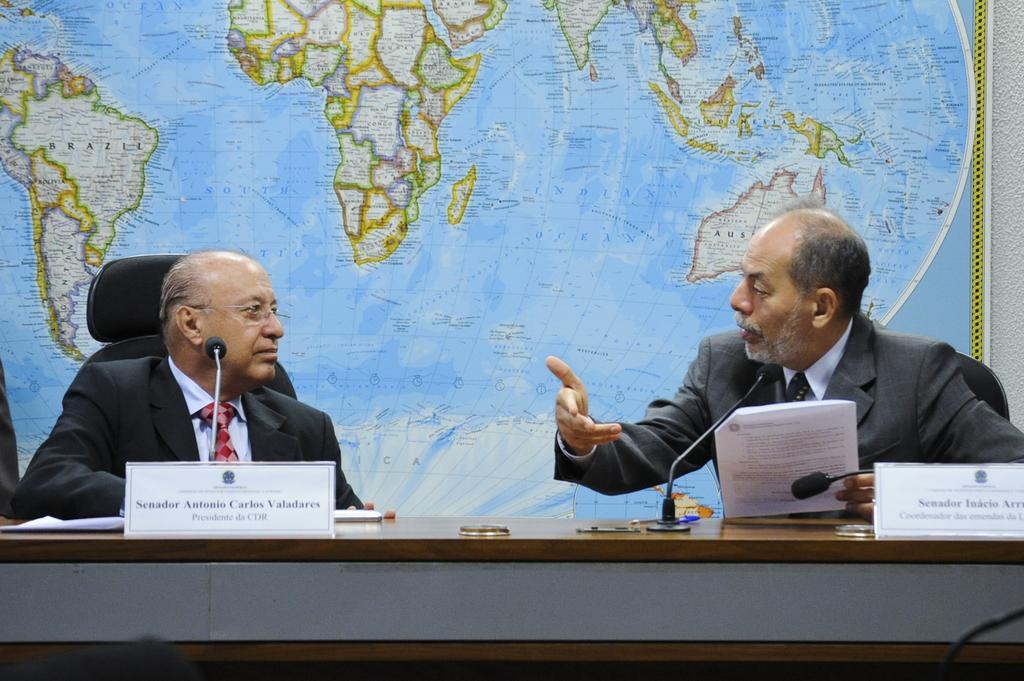Please provide a concise description of this image. In the background we can see a map board on the wall. In this picture we can see the men sitting on the chairs and it seems like they are discussing. On the table we can see the name boards, microphones, papers and few objects. A man on the right side is holding papers in the hand. 